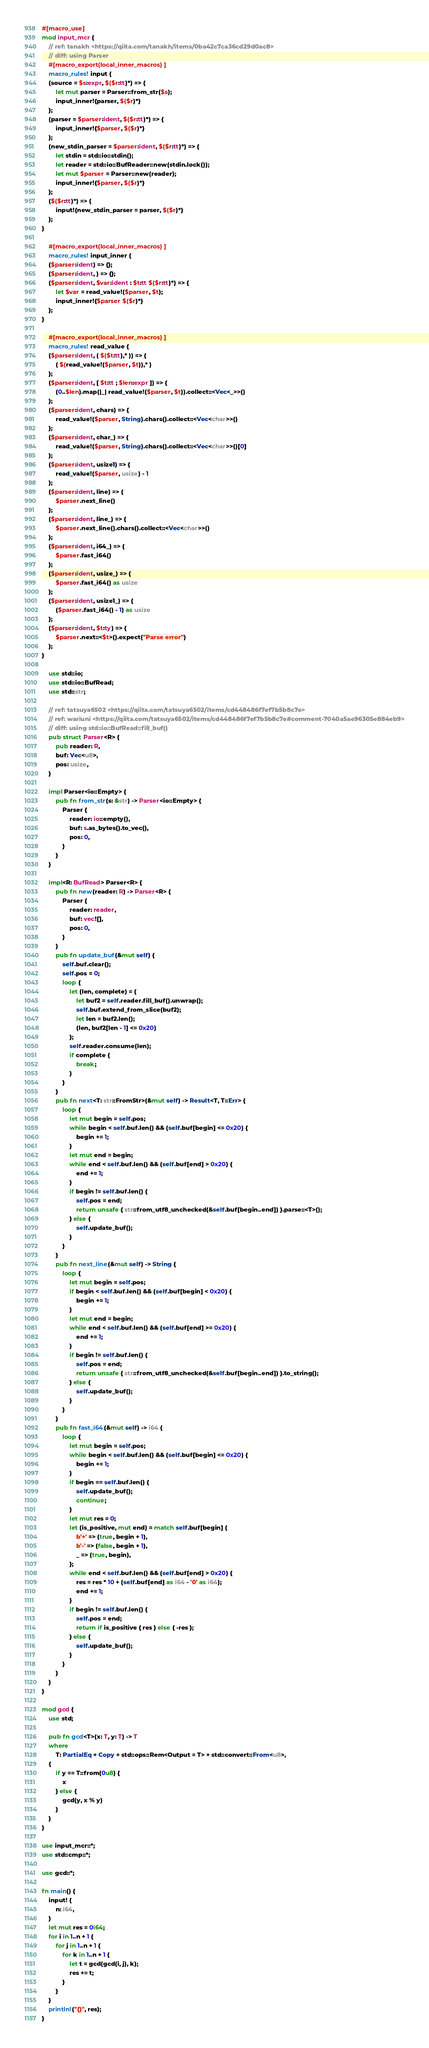Convert code to text. <code><loc_0><loc_0><loc_500><loc_500><_Rust_>#[macro_use]
mod input_mcr {
    // ref: tanakh <https://qiita.com/tanakh/items/0ba42c7ca36cd29d0ac8>
    // diff: using Parser
    #[macro_export(local_inner_macros)]
    macro_rules! input {
    (source = $s:expr, $($r:tt)*) => {
        let mut parser = Parser::from_str($s);
        input_inner!{parser, $($r)*}
    };
    (parser = $parser:ident, $($r:tt)*) => {
        input_inner!{$parser, $($r)*}
    };
    (new_stdin_parser = $parser:ident, $($r:tt)*) => {
        let stdin = std::io::stdin();
        let reader = std::io::BufReader::new(stdin.lock());
        let mut $parser = Parser::new(reader);
        input_inner!{$parser, $($r)*}
    };
    ($($r:tt)*) => {
        input!{new_stdin_parser = parser, $($r)*}
    };
}

    #[macro_export(local_inner_macros)]
    macro_rules! input_inner {
    ($parser:ident) => {};
    ($parser:ident, ) => {};
    ($parser:ident, $var:ident : $t:tt $($r:tt)*) => {
        let $var = read_value!($parser, $t);
        input_inner!{$parser $($r)*}
    };
}

    #[macro_export(local_inner_macros)]
    macro_rules! read_value {
    ($parser:ident, ( $($t:tt),* )) => {
        ( $(read_value!($parser, $t)),* )
    };
    ($parser:ident, [ $t:tt ; $len:expr ]) => {
        (0..$len).map(|_| read_value!($parser, $t)).collect::<Vec<_>>()
    };
    ($parser:ident, chars) => {
        read_value!($parser, String).chars().collect::<Vec<char>>()
    };
    ($parser:ident, char_) => {
        read_value!($parser, String).chars().collect::<Vec<char>>()[0]
    };
    ($parser:ident, usize1) => {
        read_value!($parser, usize) - 1
    };
    ($parser:ident, line) => {
        $parser.next_line()
    };
    ($parser:ident, line_) => {
        $parser.next_line().chars().collect::<Vec<char>>()
    };
    ($parser:ident, i64_) => {
        $parser.fast_i64()
    };
    ($parser:ident, usize_) => {
        $parser.fast_i64() as usize
    };
    ($parser:ident, usize1_) => {
        ($parser.fast_i64() - 1) as usize
    };
    ($parser:ident, $t:ty) => {
        $parser.next::<$t>().expect("Parse error")
    };
}

    use std::io;
    use std::io::BufRead;
    use std::str;

    // ref: tatsuya6502 <https://qiita.com/tatsuya6502/items/cd448486f7ef7b5b8c7e>
    // ref: wariuni <https://qiita.com/tatsuya6502/items/cd448486f7ef7b5b8c7e#comment-7040a5ae96305e884eb9>
    // diff: using std::io::BufRead::fill_buf()
    pub struct Parser<R> {
        pub reader: R,
        buf: Vec<u8>,
        pos: usize,
    }

    impl Parser<io::Empty> {
        pub fn from_str(s: &str) -> Parser<io::Empty> {
            Parser {
                reader: io::empty(),
                buf: s.as_bytes().to_vec(),
                pos: 0,
            }
        }
    }

    impl<R: BufRead> Parser<R> {
        pub fn new(reader: R) -> Parser<R> {
            Parser {
                reader: reader,
                buf: vec![],
                pos: 0,
            }
        }
        pub fn update_buf(&mut self) {
            self.buf.clear();
            self.pos = 0;
            loop {
                let (len, complete) = {
                    let buf2 = self.reader.fill_buf().unwrap();
                    self.buf.extend_from_slice(buf2);
                    let len = buf2.len();
                    (len, buf2[len - 1] <= 0x20)
                };
                self.reader.consume(len);
                if complete {
                    break;
                }
            }
        }
        pub fn next<T: str::FromStr>(&mut self) -> Result<T, T::Err> {
            loop {
                let mut begin = self.pos;
                while begin < self.buf.len() && (self.buf[begin] <= 0x20) {
                    begin += 1;
                }
                let mut end = begin;
                while end < self.buf.len() && (self.buf[end] > 0x20) {
                    end += 1;
                }
                if begin != self.buf.len() {
                    self.pos = end;
                    return unsafe { str::from_utf8_unchecked(&self.buf[begin..end]) }.parse::<T>();
                } else {
                    self.update_buf();
                }
            }
        }
        pub fn next_line(&mut self) -> String {
            loop {
                let mut begin = self.pos;
                if begin < self.buf.len() && (self.buf[begin] < 0x20) {
                    begin += 1;
                }
                let mut end = begin;
                while end < self.buf.len() && (self.buf[end] >= 0x20) {
                    end += 1;
                }
                if begin != self.buf.len() {
                    self.pos = end;
                    return unsafe { str::from_utf8_unchecked(&self.buf[begin..end]) }.to_string();
                } else {
                    self.update_buf();
                }
            }
        }
        pub fn fast_i64(&mut self) -> i64 {
            loop {
                let mut begin = self.pos;
                while begin < self.buf.len() && (self.buf[begin] <= 0x20) {
                    begin += 1;
                }
                if begin == self.buf.len() {
                    self.update_buf();
                    continue;
                }
                let mut res = 0;
                let (is_positive, mut end) = match self.buf[begin] {
                    b'+' => (true, begin + 1),
                    b'-' => (false, begin + 1),
                    _ => (true, begin),
                };
                while end < self.buf.len() && (self.buf[end] > 0x20) {
                    res = res * 10 + (self.buf[end] as i64 - '0' as i64);
                    end += 1;
                }
                if begin != self.buf.len() {
                    self.pos = end;
                    return if is_positive { res } else { -res };
                } else {
                    self.update_buf();
                }
            }
        }
    }
}

mod gcd {
    use std;

    pub fn gcd<T>(x: T, y: T) -> T
    where
        T: PartialEq + Copy + std::ops::Rem<Output = T> + std::convert::From<u8>,
    {
        if y == T::from(0u8) {
            x
        } else {
            gcd(y, x % y)
        }
    }
}

use input_mcr::*;
use std::cmp::*;

use gcd::*;

fn main() {
    input! {
        n: i64,
    }
    let mut res = 0i64;
    for i in 1..n + 1 {
        for j in 1..n + 1 {
            for k in 1..n + 1 {
                let t = gcd(gcd(i, j), k);
                res += t;
            }
        }
    }
    println!("{}", res);
}

</code> 